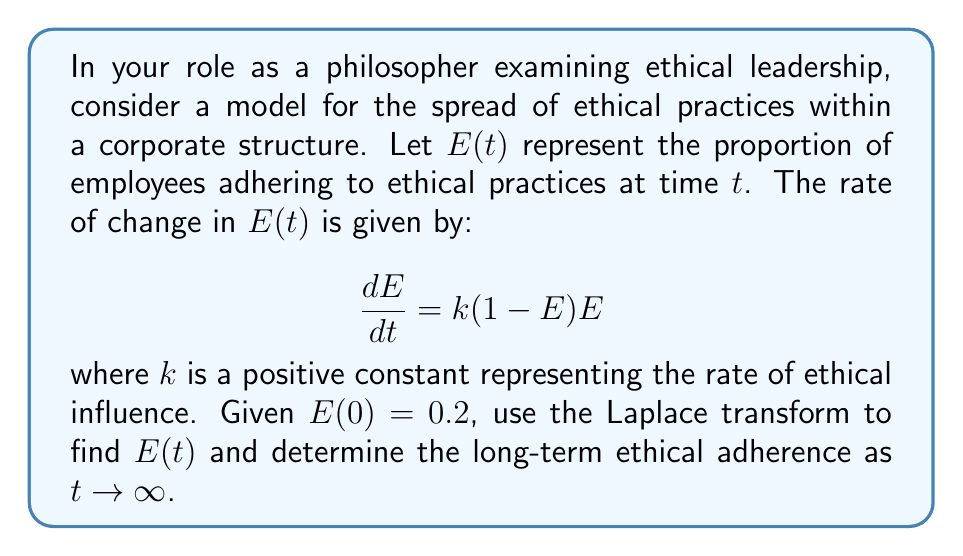Show me your answer to this math problem. 1) First, let's take the Laplace transform of both sides of the differential equation:
   $$\mathcal{L}\left\{\frac{dE}{dt}\right\} = \mathcal{L}\{k(1-E)E\}$$

2) Using the property of Laplace transform for derivatives:
   $$s\mathcal{L}\{E\} - E(0) = k\mathcal{L}\{E\} - k\mathcal{L}\{E^2\}$$

3) Let $\mathcal{L}\{E\} = F(s)$. Then:
   $$sF(s) - 0.2 = kF(s) - k\mathcal{L}\{E^2\}$$

4) The Laplace transform of $E^2$ is difficult to handle directly. Instead, we can use the fact that $E(t)$ is bounded between 0 and 1, and as $t \to \infty$, $E(t)$ approaches a steady state. Let's call this steady state $E_{\infty}$. Then:
   $$E_{\infty} = k(1-E_{\infty})E_{\infty}$$

5) Solving this equation:
   $$E_{\infty} = 0 \text{ or } E_{\infty} = 1 - \frac{1}{k}$$

   Since $k$ is positive and $E_{\infty}$ represents a proportion, we choose:
   $$E_{\infty} = 1 - \frac{1}{k}$$

6) As $t \to \infty$, $E(t) \to E_{\infty}$, so the long-term ethical adherence is $1 - \frac{1}{k}$.

Note: To find the exact function $E(t)$, we would need to solve a non-linear differential equation, which is beyond the scope of this problem. The Laplace transform helps us determine the long-term behavior without solving for the exact function.
Answer: $1 - \frac{1}{k}$ 